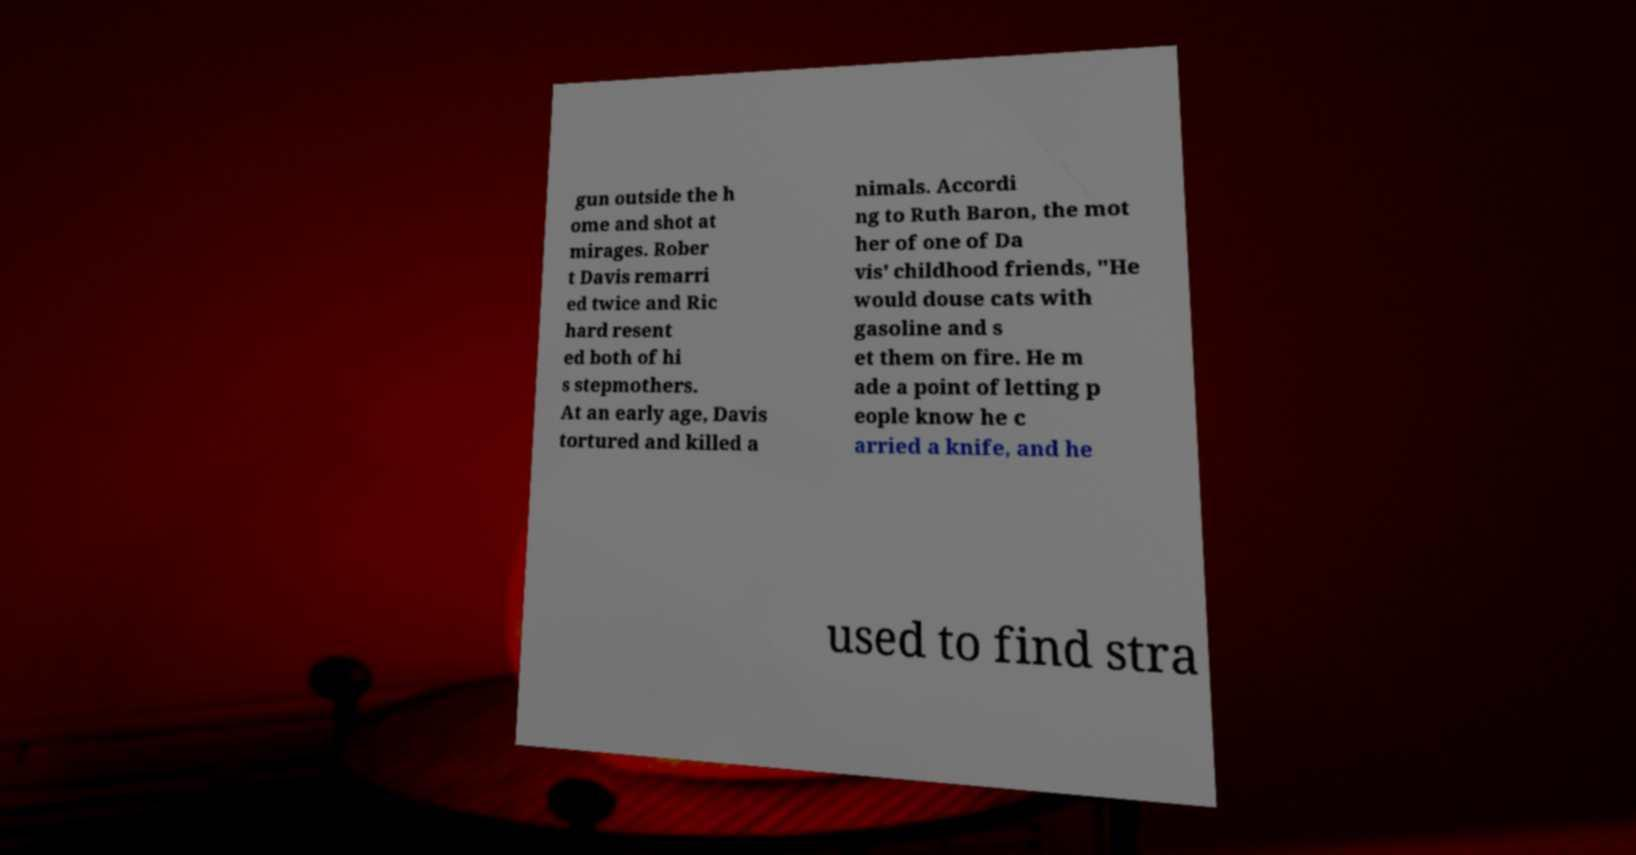Please read and relay the text visible in this image. What does it say? gun outside the h ome and shot at mirages. Rober t Davis remarri ed twice and Ric hard resent ed both of hi s stepmothers. At an early age, Davis tortured and killed a nimals. Accordi ng to Ruth Baron, the mot her of one of Da vis' childhood friends, "He would douse cats with gasoline and s et them on fire. He m ade a point of letting p eople know he c arried a knife, and he used to find stra 